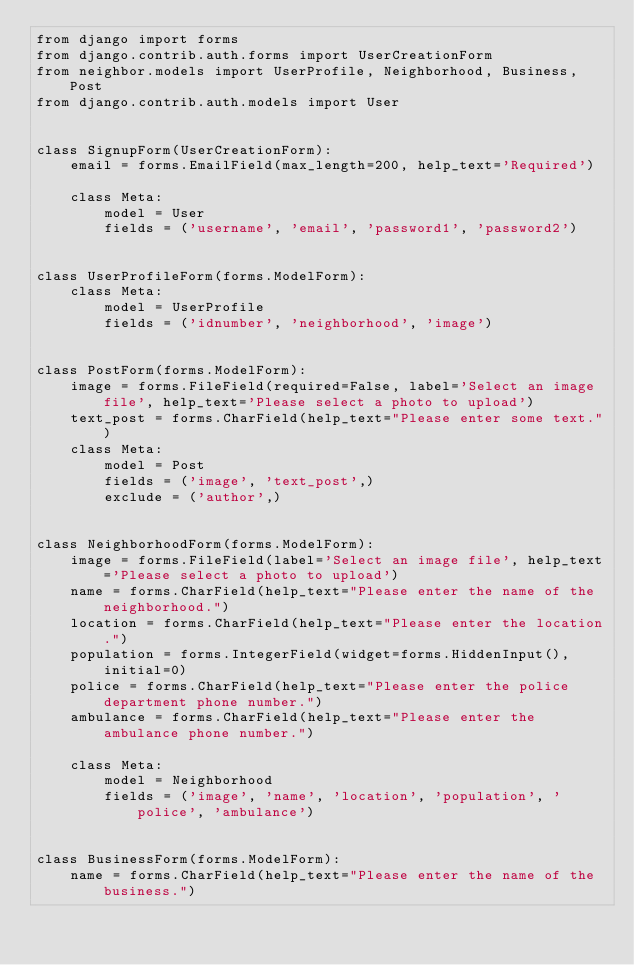<code> <loc_0><loc_0><loc_500><loc_500><_Python_>from django import forms
from django.contrib.auth.forms import UserCreationForm
from neighbor.models import UserProfile, Neighborhood, Business, Post
from django.contrib.auth.models import User


class SignupForm(UserCreationForm):
    email = forms.EmailField(max_length=200, help_text='Required')

    class Meta:
        model = User
        fields = ('username', 'email', 'password1', 'password2')


class UserProfileForm(forms.ModelForm):
    class Meta:
        model = UserProfile
        fields = ('idnumber', 'neighborhood', 'image')


class PostForm(forms.ModelForm):
    image = forms.FileField(required=False, label='Select an image file', help_text='Please select a photo to upload')
    text_post = forms.CharField(help_text="Please enter some text.")
    class Meta:
        model = Post
        fields = ('image', 'text_post',)
        exclude = ('author',)


class NeighborhoodForm(forms.ModelForm):
    image = forms.FileField(label='Select an image file', help_text='Please select a photo to upload')
    name = forms.CharField(help_text="Please enter the name of the neighborhood.")
    location = forms.CharField(help_text="Please enter the location.")
    population = forms.IntegerField(widget=forms.HiddenInput(), initial=0)
    police = forms.CharField(help_text="Please enter the police department phone number.")
    ambulance = forms.CharField(help_text="Please enter the ambulance phone number.")

    class Meta:
        model = Neighborhood
        fields = ('image', 'name', 'location', 'population', 'police', 'ambulance')


class BusinessForm(forms.ModelForm):
    name = forms.CharField(help_text="Please enter the name of the business.")</code> 